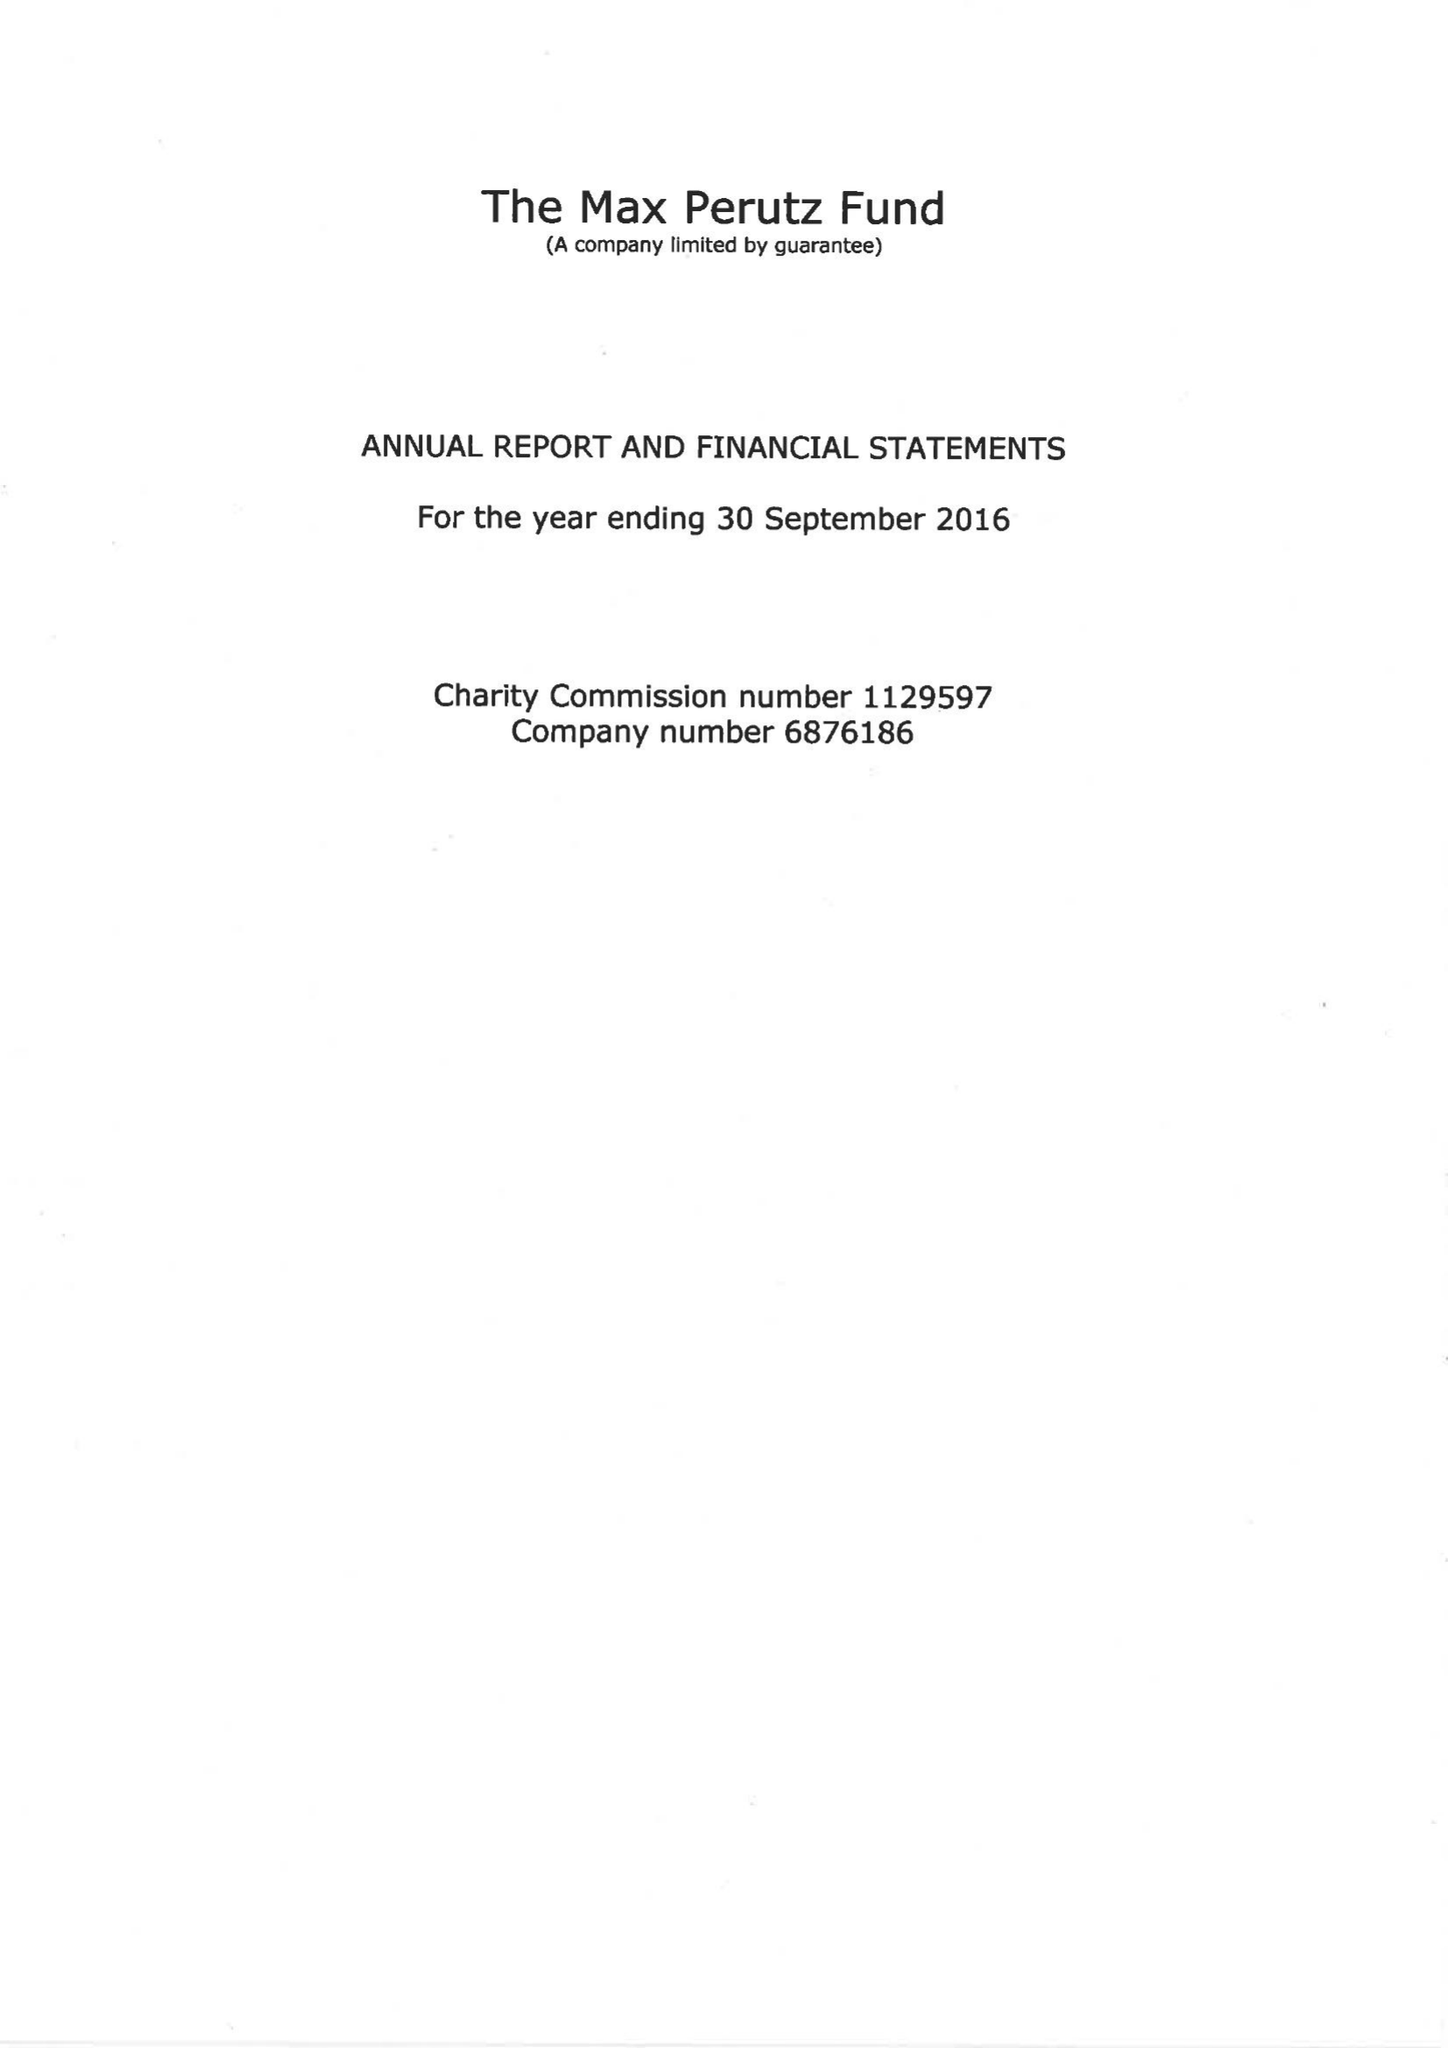What is the value for the income_annually_in_british_pounds?
Answer the question using a single word or phrase. 204522.00 